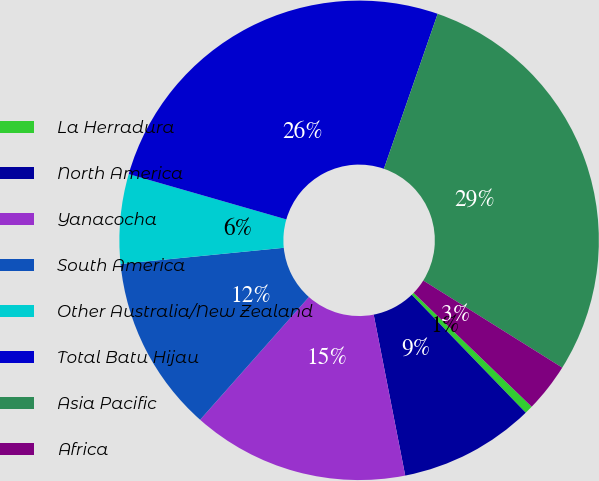Convert chart to OTSL. <chart><loc_0><loc_0><loc_500><loc_500><pie_chart><fcel>La Herradura<fcel>North America<fcel>Yanacocha<fcel>South America<fcel>Other Australia/New Zealand<fcel>Total Batu Hijau<fcel>Asia Pacific<fcel>Africa<nl><fcel>0.56%<fcel>9.15%<fcel>14.62%<fcel>11.89%<fcel>6.03%<fcel>25.86%<fcel>28.6%<fcel>3.3%<nl></chart> 